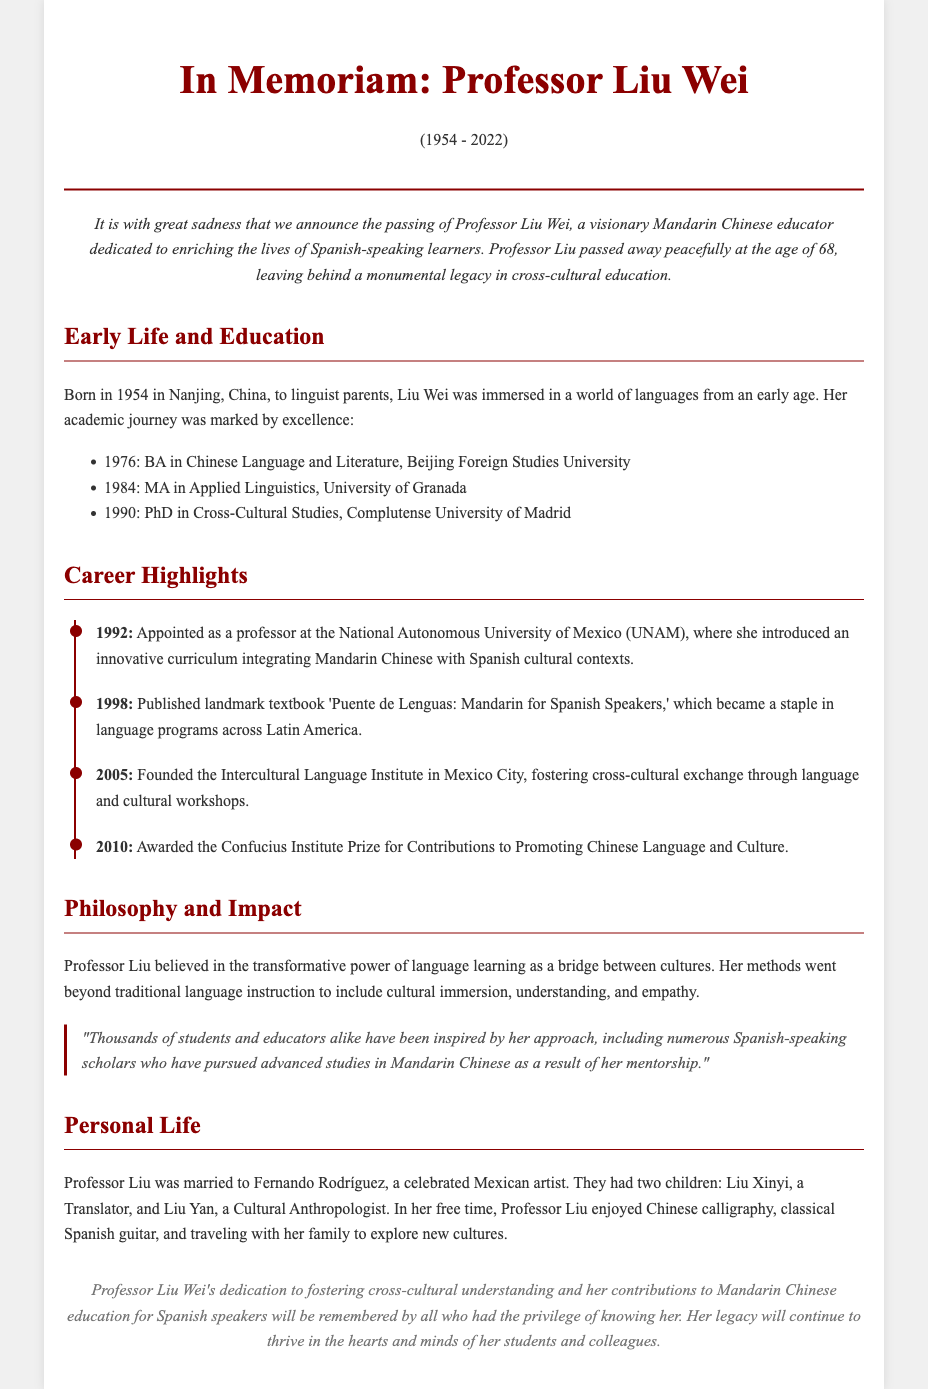What was Professor Liu Wei's birth year? The document states that Liu Wei was born in 1954.
Answer: 1954 What notable textbook did she publish? The obituary mentions the textbook titled 'Puente de Lenguas: Mandarin for Spanish Speakers.'
Answer: Puente de Lenguas: Mandarin for Spanish Speakers Which university did she join in 1992? It is stated that she was appointed as a professor at the National Autonomous University of Mexico (UNAM) in 1992.
Answer: National Autonomous University of Mexico (UNAM) What prize did Professor Liu receive in 2010? The document notes that she was awarded the Confucius Institute Prize for Contributions to Promoting Chinese Language and Culture in 2010.
Answer: Confucius Institute Prize How many children did Professor Liu have? The obituary indicates that she had two children: Liu Xinyi and Liu Yan.
Answer: Two What did Professor Liu emphasize in her language teaching philosophy? The document highlights that she believed in the transformative power of language learning as a bridge between cultures.
Answer: Transformative power of language learning Who was Professor Liu's husband? The obituary mentions that she was married to Fernando Rodríguez, a celebrated Mexican artist.
Answer: Fernando Rodríguez What year did Professor Liu pass away? The document states that Professor Liu passed away in 2022.
Answer: 2022 